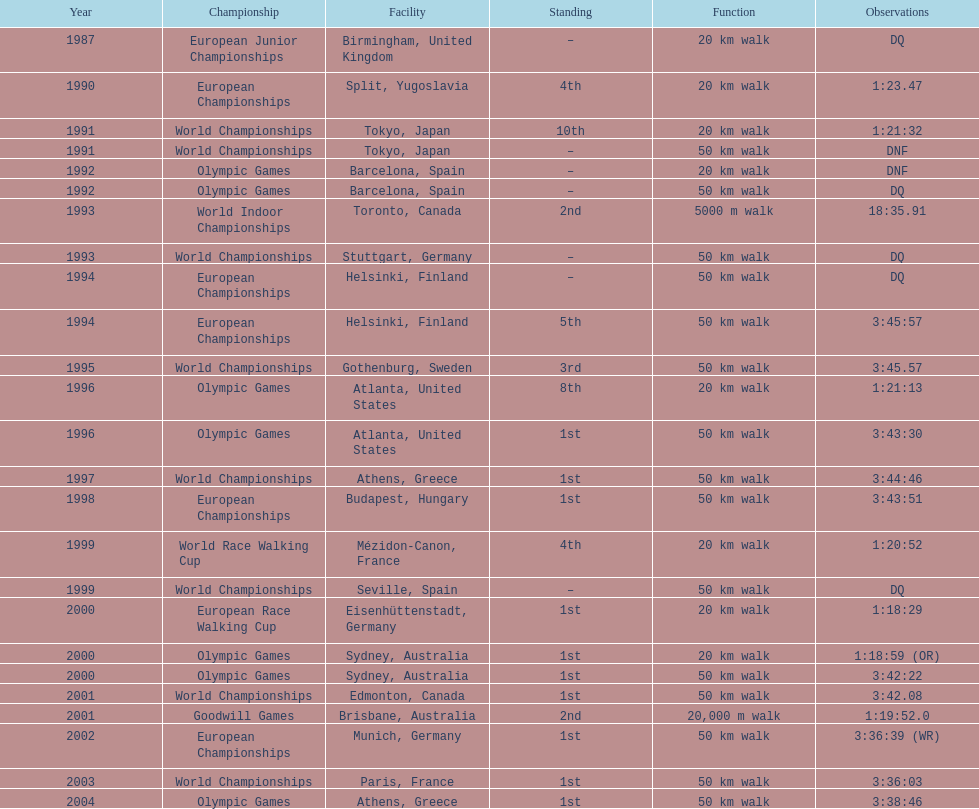How many events were at least 50 km? 17. 